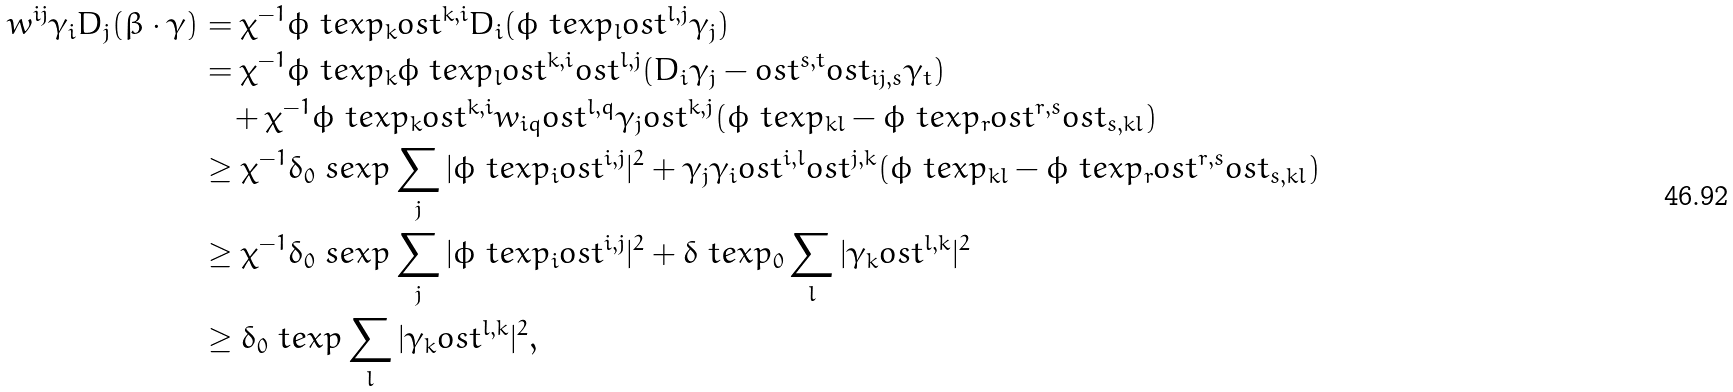Convert formula to latex. <formula><loc_0><loc_0><loc_500><loc_500>w ^ { i j } \gamma _ { i } D _ { j } ( \beta \cdot \gamma ) & = \chi ^ { - 1 } \phi \ t e x p _ { k } o s t ^ { k , i } D _ { i } ( \phi \ t e x p _ { l } o s t ^ { l , j } \gamma _ { j } ) \\ & = \chi ^ { - 1 } \phi \ t e x p _ { k } \phi \ t e x p _ { l } o s t ^ { k , i } o s t ^ { l , j } ( D _ { i } \gamma _ { j } - o s t ^ { s , t } o s t _ { i j , s } \gamma _ { t } ) \\ & \quad + \chi ^ { - 1 } \phi \ t e x p _ { k } o s t ^ { k , i } w _ { i q } o s t ^ { l , q } \gamma _ { j } o s t ^ { k , j } ( \phi \ t e x p _ { k l } - \phi \ t e x p _ { r } o s t ^ { r , s } o s t _ { s , k l } ) \\ & \geq \chi ^ { - 1 } \delta _ { 0 } \ s e x p \sum _ { j } | \phi \ t e x p _ { i } o s t ^ { i , j } | ^ { 2 } + \gamma _ { j } \gamma _ { i } o s t ^ { i , l } o s t ^ { j , k } ( \phi \ t e x p _ { k l } - \phi \ t e x p _ { r } o s t ^ { r , s } o s t _ { s , k l } ) \\ & \geq \chi ^ { - 1 } \delta _ { 0 } \ s e x p \sum _ { j } | \phi \ t e x p _ { i } o s t ^ { i , j } | ^ { 2 } + \delta \ t e x p _ { 0 } \sum _ { l } | \gamma _ { k } o s t ^ { l , k } | ^ { 2 } \\ & \geq \delta _ { 0 } \ t e x p \sum _ { l } | \gamma _ { k } o s t ^ { l , k } | ^ { 2 } ,</formula> 